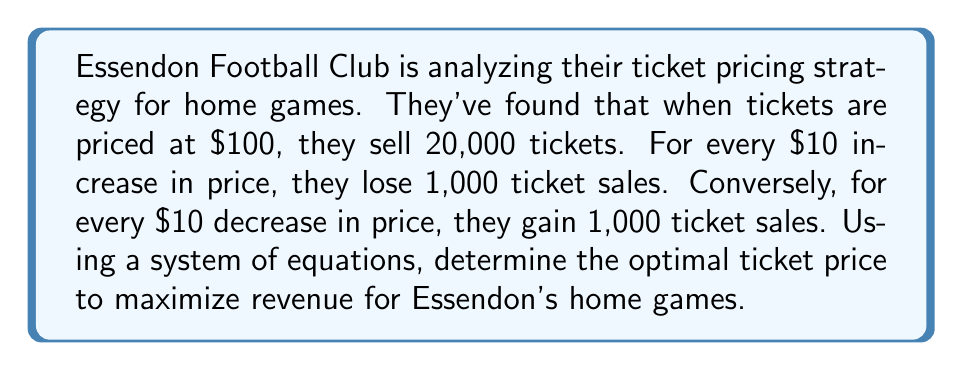Show me your answer to this math problem. Let's approach this step-by-step:

1) Let $x$ be the change in price from $100 in multiples of $10. So, the price $P$ is given by:
   $P = 100 + 10x$

2) The number of tickets sold $Q$ is given by:
   $Q = 20,000 - 1,000x$

3) The revenue $R$ is price times quantity:
   $R = P \cdot Q = (100 + 10x)(20,000 - 1,000x)$

4) Expand this equation:
   $R = 2,000,000 + 200,000x - 100,000x - 10,000x^2$
   $R = 2,000,000 + 100,000x - 10,000x^2$

5) To find the maximum revenue, we need to find where the derivative of $R$ with respect to $x$ is zero:
   $\frac{dR}{dx} = 100,000 - 20,000x$

6) Set this equal to zero and solve:
   $100,000 - 20,000x = 0$
   $20,000x = 100,000$
   $x = 5$

7) This means the optimal price change is $50 (5 * $10).

8) Therefore, the optimal price is $100 + $50 = $150.

9) We can verify this is a maximum by checking the second derivative is negative:
   $\frac{d^2R}{dx^2} = -20,000$, which is indeed negative.

10) To calculate the maximum revenue:
    $R = 2,000,000 + 100,000(5) - 10,000(5^2)$
    $R = 2,000,000 + 500,000 - 250,000 = 2,250,000$
Answer: $150 per ticket, generating $2,250,000 in revenue 